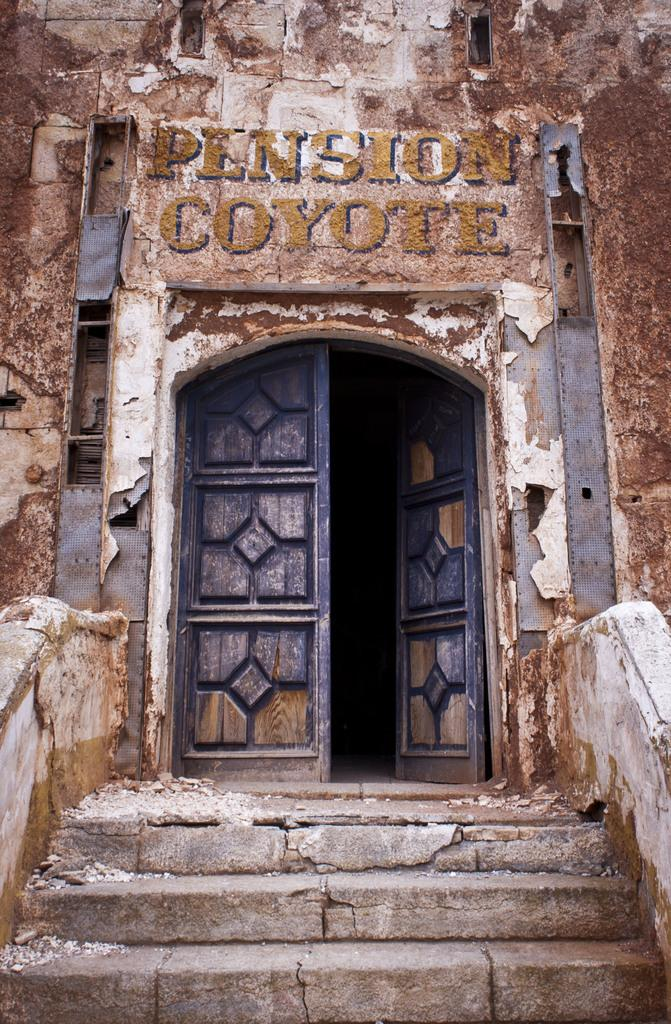What type of structure is visible in the image? There is a building in the image. What can be seen on the wall of the building? There is text on the wall of the building. What is located in the foreground of the image? There is a door and a staircase in the foreground of the image. What type of disease is being treated in the building in the image? There is no indication of a disease or any medical treatment in the image; it simply shows a building with text on the wall and a door and staircase in the foreground. 